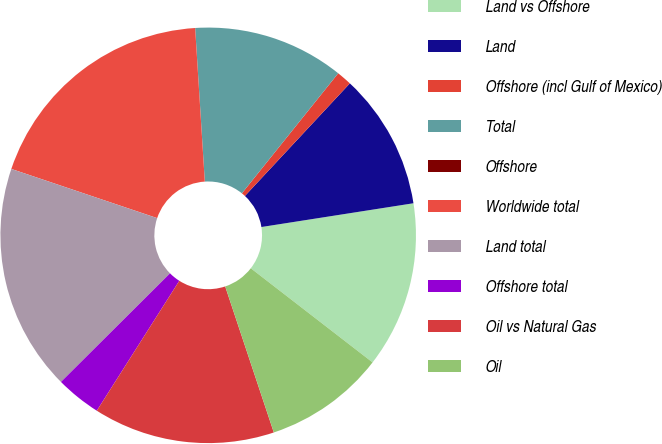Convert chart. <chart><loc_0><loc_0><loc_500><loc_500><pie_chart><fcel>Land vs Offshore<fcel>Land<fcel>Offshore (incl Gulf of Mexico)<fcel>Total<fcel>Offshore<fcel>Worldwide total<fcel>Land total<fcel>Offshore total<fcel>Oil vs Natural Gas<fcel>Oil<nl><fcel>12.94%<fcel>10.59%<fcel>1.18%<fcel>11.76%<fcel>0.0%<fcel>18.82%<fcel>17.64%<fcel>3.53%<fcel>14.12%<fcel>9.41%<nl></chart> 